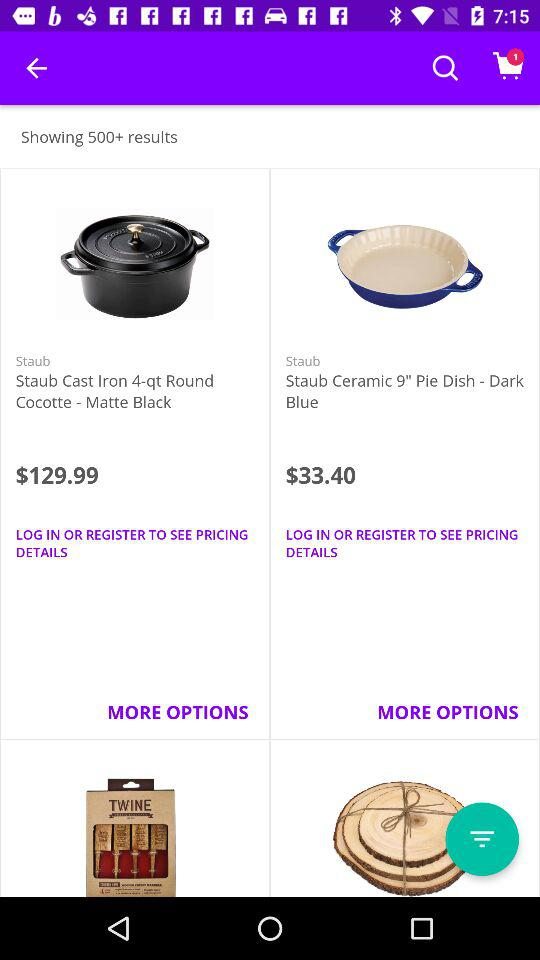How many results in total are there? There are 500+ results in total. 